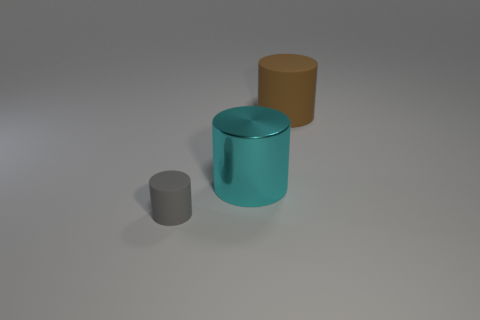Are there any small gray cylinders in front of the gray cylinder?
Make the answer very short. No. Is there another big brown cylinder made of the same material as the brown cylinder?
Make the answer very short. No. What number of cylinders are either red metallic objects or big cyan objects?
Your answer should be very brief. 1. Is the number of tiny cylinders that are right of the brown matte object greater than the number of big metallic things left of the tiny rubber cylinder?
Offer a terse response. No. What number of tiny rubber objects are the same color as the small matte cylinder?
Ensure brevity in your answer.  0. There is a object that is the same material as the big brown cylinder; what is its size?
Your answer should be compact. Small. What number of things are either rubber cylinders to the left of the brown cylinder or cyan metal objects?
Provide a succinct answer. 2. There is a metallic thing that is on the left side of the brown matte cylinder; is its color the same as the large matte thing?
Your answer should be compact. No. The other matte thing that is the same shape as the tiny gray rubber thing is what size?
Your answer should be very brief. Large. There is a matte thing in front of the rubber cylinder behind the rubber cylinder left of the big brown rubber object; what is its color?
Provide a succinct answer. Gray. 